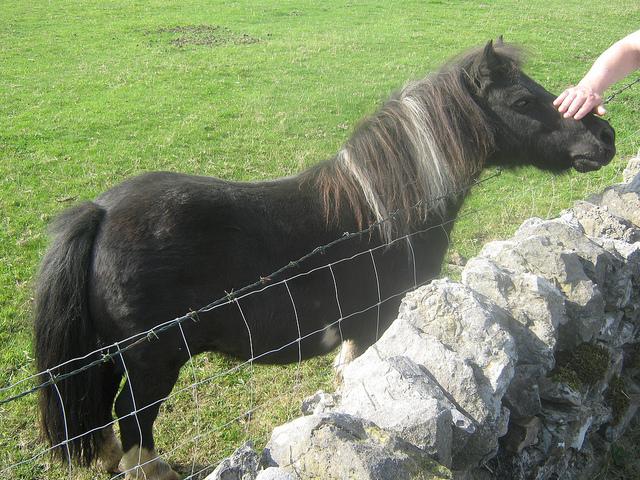What color is the horse?
Write a very short answer. Black. What animal is standing?
Quick response, please. Horse. What is the fence made out of?
Be succinct. Wire. Does the animal have horns?
Give a very brief answer. No. Can you see a hand in the picture?
Answer briefly. Yes. What is on this animals head?
Keep it brief. Hand. What kind of animals are these?
Give a very brief answer. Pony. 